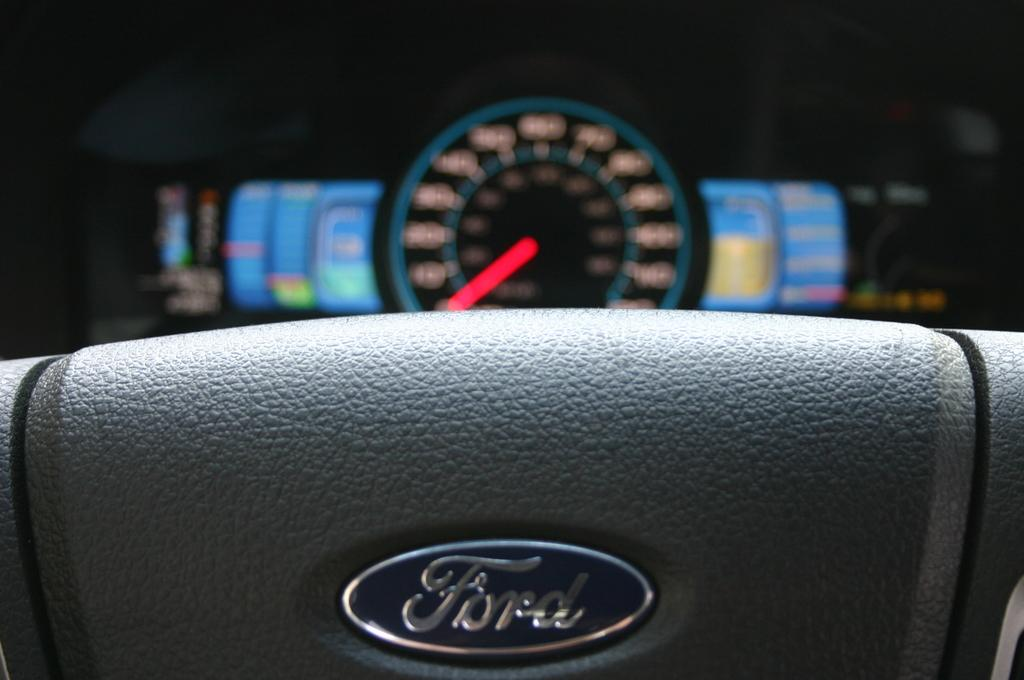What is the main object in the picture? There is a steering wheel in the picture. Is there any branding or identification on the steering wheel? Yes, the steering wheel has a logo. What other instrument related to driving can be seen in the picture? There is a speedometer in the backdrop. Can you describe the speedometer's current state? The speedometer has an indicator and lights. What type of plant can be seen growing near the steering wheel in the image? There is no plant visible in the image; it only features a steering wheel and a speedometer. How does the sail affect the speedometer's readings in the image? There is no sail present in the image, so it cannot affect the speedometer's readings. 